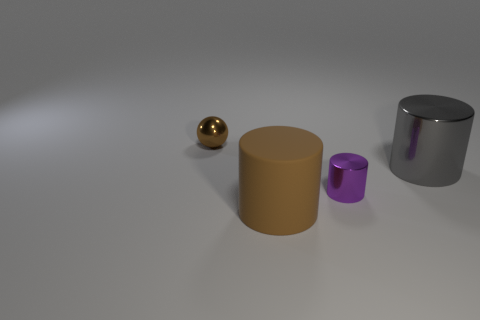Are there any other things that have the same material as the brown cylinder?
Give a very brief answer. No. What is the color of the other small object that is the same shape as the brown matte object?
Offer a very short reply. Purple. Does the object behind the gray metal object have the same size as the big metallic cylinder?
Your answer should be compact. No. The large object that is the same color as the tiny ball is what shape?
Provide a short and direct response. Cylinder. What number of other big objects have the same material as the big gray thing?
Your response must be concise. 0. What material is the brown thing that is in front of the brown thing to the left of the brown thing in front of the tiny brown ball made of?
Offer a terse response. Rubber. The tiny thing that is left of the tiny metallic object on the right side of the small brown object is what color?
Give a very brief answer. Brown. The thing that is the same size as the brown rubber cylinder is what color?
Provide a succinct answer. Gray. What number of big objects are either green balls or cylinders?
Your response must be concise. 2. Are there more big cylinders that are left of the tiny purple object than gray things on the left side of the tiny sphere?
Your response must be concise. Yes. 